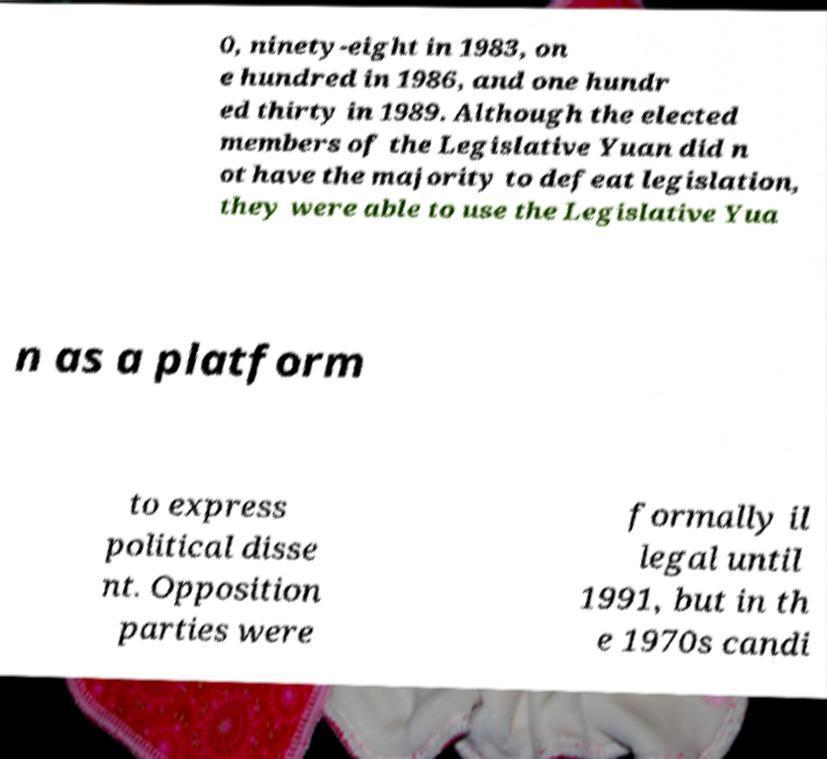Can you accurately transcribe the text from the provided image for me? 0, ninety-eight in 1983, on e hundred in 1986, and one hundr ed thirty in 1989. Although the elected members of the Legislative Yuan did n ot have the majority to defeat legislation, they were able to use the Legislative Yua n as a platform to express political disse nt. Opposition parties were formally il legal until 1991, but in th e 1970s candi 